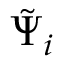Convert formula to latex. <formula><loc_0><loc_0><loc_500><loc_500>\tilde { \Psi } _ { i }</formula> 